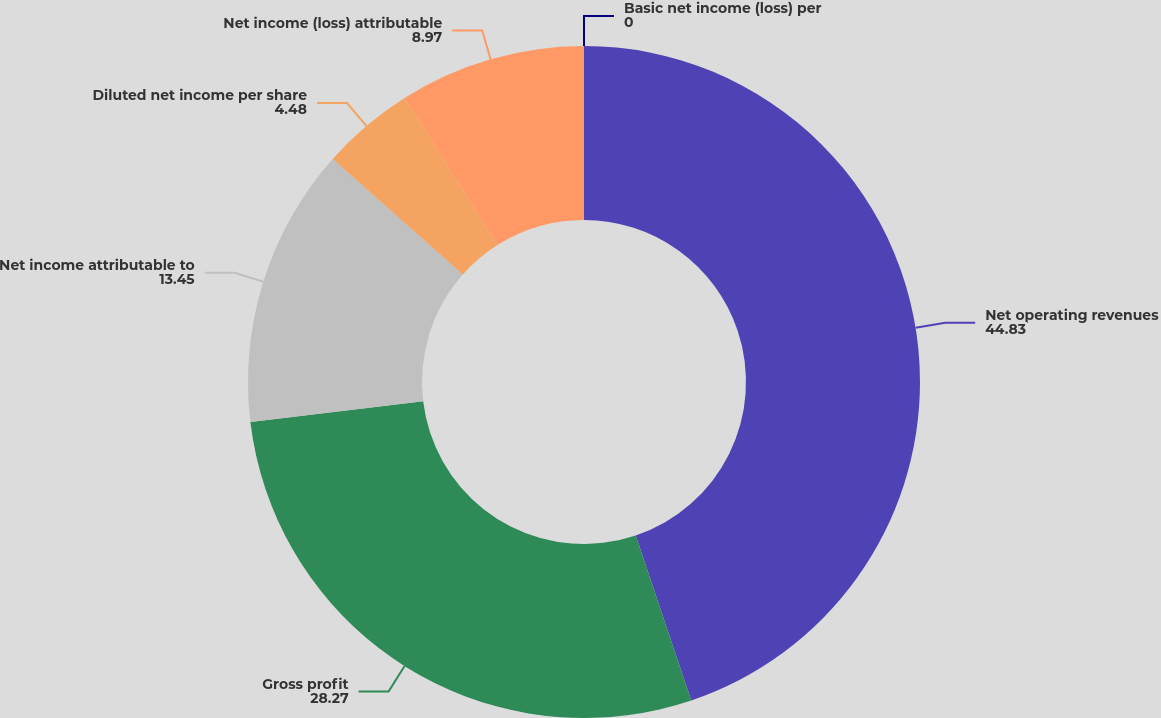Convert chart to OTSL. <chart><loc_0><loc_0><loc_500><loc_500><pie_chart><fcel>Net operating revenues<fcel>Gross profit<fcel>Net income attributable to<fcel>Diluted net income per share<fcel>Net income (loss) attributable<fcel>Basic net income (loss) per<nl><fcel>44.83%<fcel>28.27%<fcel>13.45%<fcel>4.48%<fcel>8.97%<fcel>0.0%<nl></chart> 